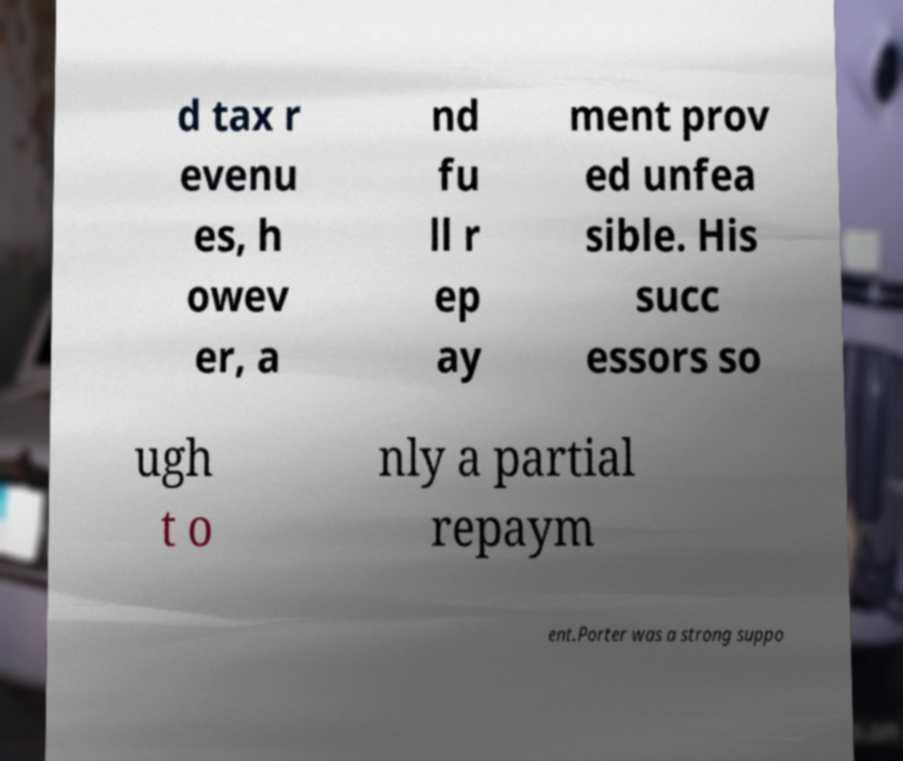Could you assist in decoding the text presented in this image and type it out clearly? d tax r evenu es, h owev er, a nd fu ll r ep ay ment prov ed unfea sible. His succ essors so ugh t o nly a partial repaym ent.Porter was a strong suppo 